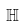Convert formula to latex. <formula><loc_0><loc_0><loc_500><loc_500>\mathbb { H }</formula> 